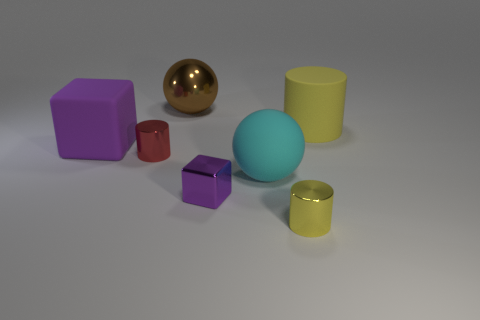Add 2 small brown objects. How many objects exist? 9 Subtract all cylinders. How many objects are left? 4 Add 7 big blue cylinders. How many big blue cylinders exist? 7 Subtract 2 yellow cylinders. How many objects are left? 5 Subtract all big matte cylinders. Subtract all small things. How many objects are left? 3 Add 6 cyan objects. How many cyan objects are left? 7 